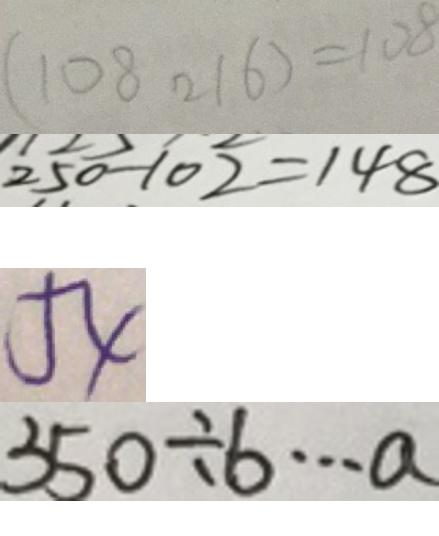Convert formula to latex. <formula><loc_0><loc_0><loc_500><loc_500>( 1 0 8 2 1 6 ) = 1 0 8 
 2 5 0 - 1 0 2 = 1 4 8 
 5 4 
 3 5 0 \div b \cdots a</formula> 